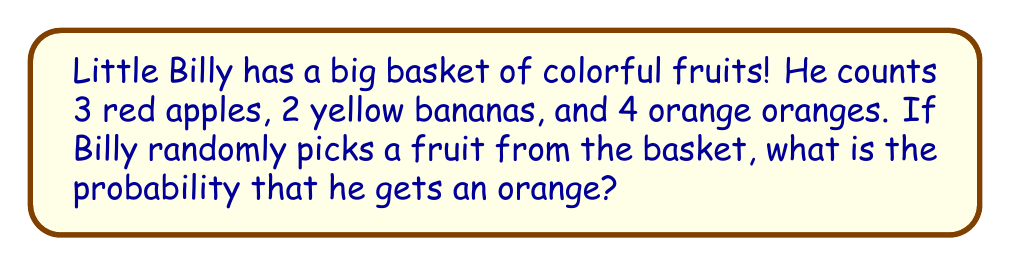Help me with this question. Let's break this down into simple steps that even a toddler can follow along with:

1. First, let's count all the fruits Billy has:
   - Red apples: 3
   - Yellow bananas: 2
   - Orange oranges: 4

2. Now, let's add them all up:
   $3 + 2 + 4 = 9$ total fruits

3. We want to know the chance of getting an orange. How many oranges are there?
   There are 4 oranges.

4. To find the probability, we divide the number of oranges by the total number of fruits:

   $$P(\text{orange}) = \frac{\text{number of oranges}}{\text{total number of fruits}} = \frac{4}{9}$$

5. We can simplify this fraction:
   $\frac{4}{9}$ cannot be simplified further, so this is our final answer!
Answer: $\frac{4}{9}$ 